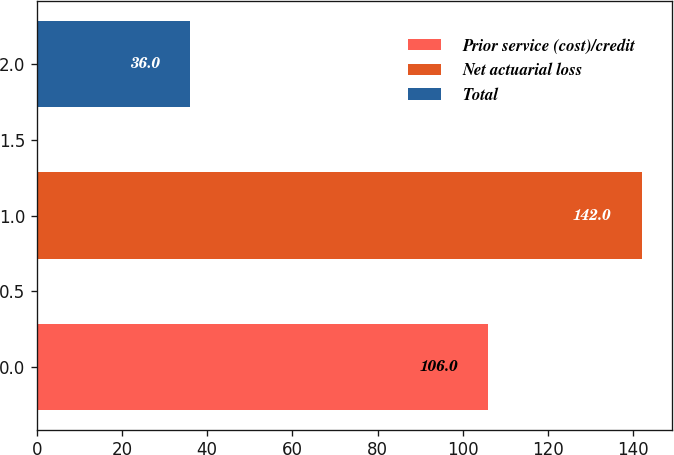<chart> <loc_0><loc_0><loc_500><loc_500><bar_chart><fcel>Prior service (cost)/credit<fcel>Net actuarial loss<fcel>Total<nl><fcel>106<fcel>142<fcel>36<nl></chart> 